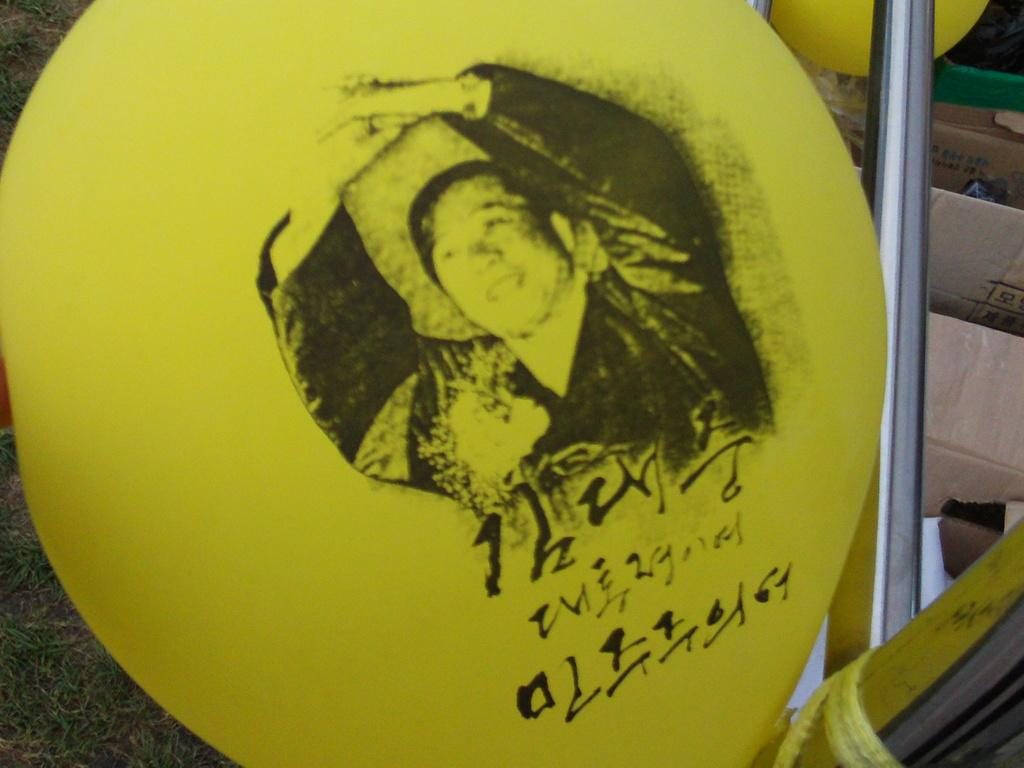What is the main object in the image? There is a yellow color board in the image. What is depicted on the color board? There is an image of a person on the board. What else can be seen on the color board? There is writing on the board. What can be seen on the right side of the image? There is a steel rod on the right side of the image. What other objects are present in the image? There are boxes in the image. How many trees are visible in the image? There are no trees visible in the image. What type of rabbit can be seen hopping on the color board? There is no rabbit present in the image. 